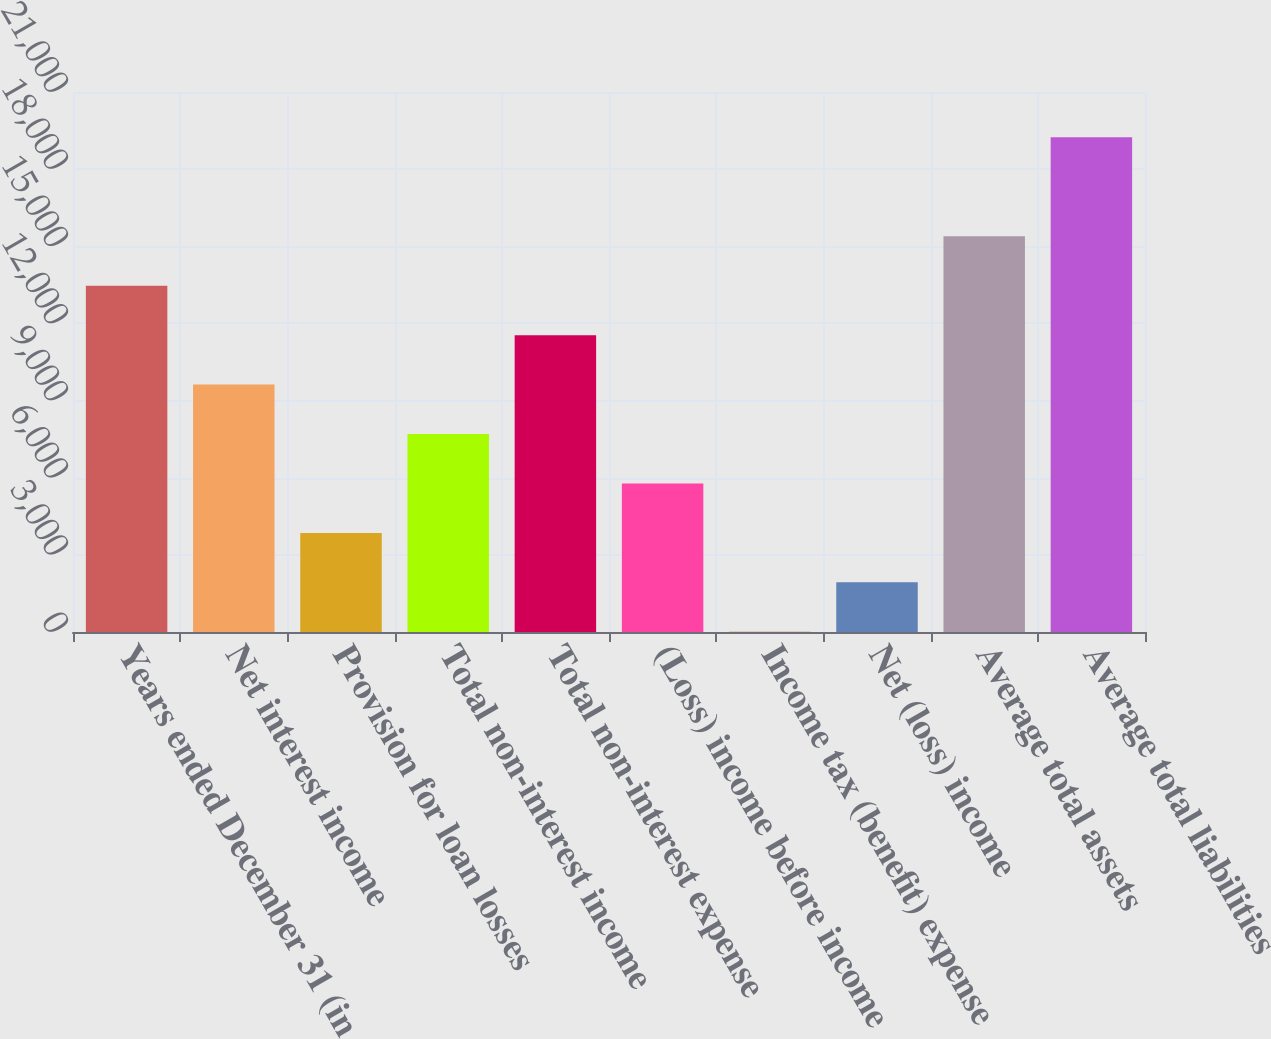Convert chart to OTSL. <chart><loc_0><loc_0><loc_500><loc_500><bar_chart><fcel>Years ended December 31 (in<fcel>Net interest income<fcel>Provision for loan losses<fcel>Total non-interest income<fcel>Total non-interest expense<fcel>(Loss) income before income<fcel>Income tax (benefit) expense<fcel>Net (loss) income<fcel>Average total assets<fcel>Average total liabilities<nl><fcel>13467.2<fcel>9621.4<fcel>3852.76<fcel>7698.52<fcel>11544.3<fcel>5775.64<fcel>7<fcel>1929.88<fcel>15390<fcel>19235.8<nl></chart> 